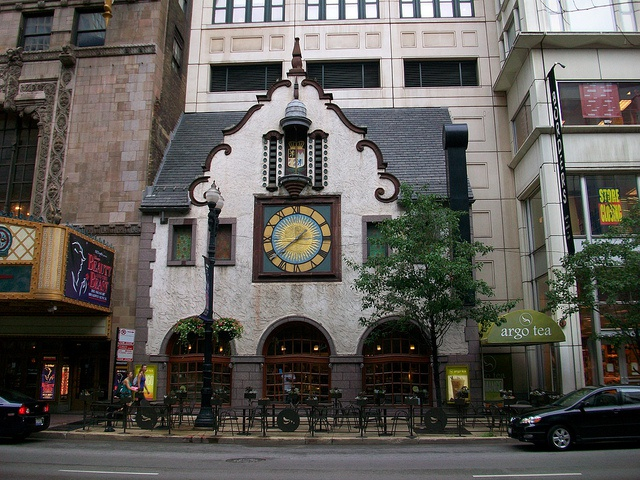Describe the objects in this image and their specific colors. I can see car in gray, black, and navy tones, clock in gray, tan, black, and blue tones, car in gray, black, and maroon tones, chair in gray and black tones, and people in gray, black, maroon, and teal tones in this image. 